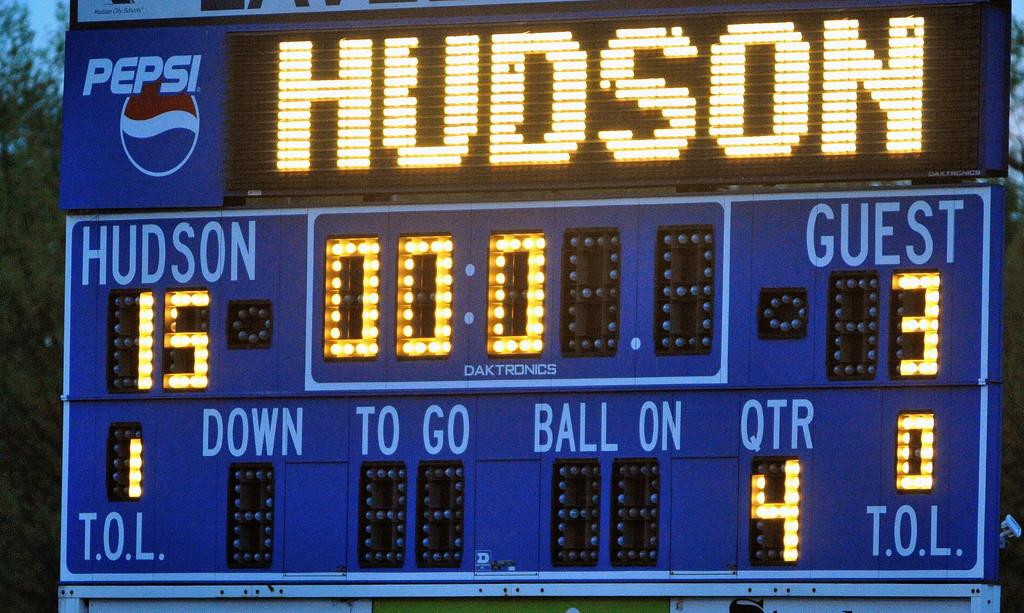<image>
Render a clear and concise summary of the photo. A scoreboard has the text "HUDSON" and "HUDSON, 